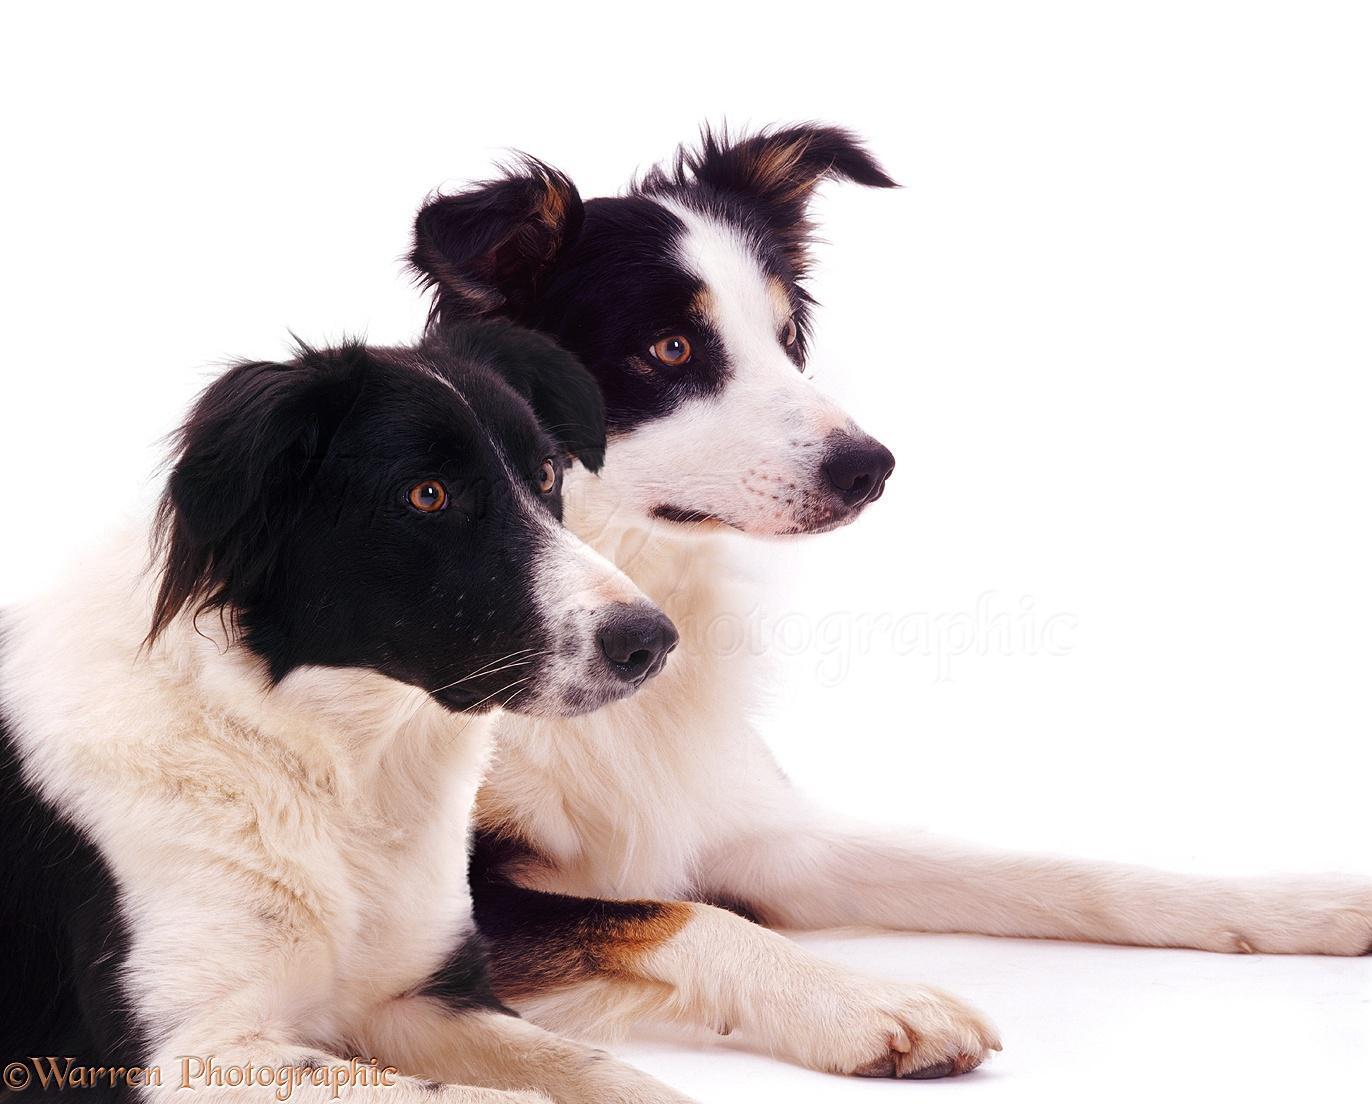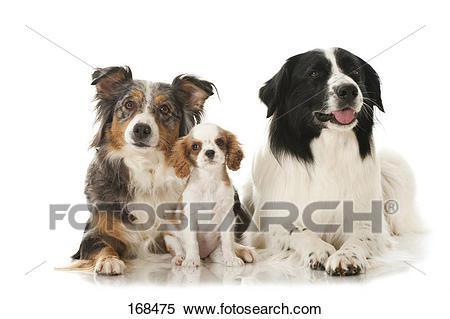The first image is the image on the left, the second image is the image on the right. Examine the images to the left and right. Is the description "At least one of the dogs is standing up in the image on the right." accurate? Answer yes or no. No. The first image is the image on the left, the second image is the image on the right. Given the left and right images, does the statement "There are at most four dogs." hold true? Answer yes or no. No. 